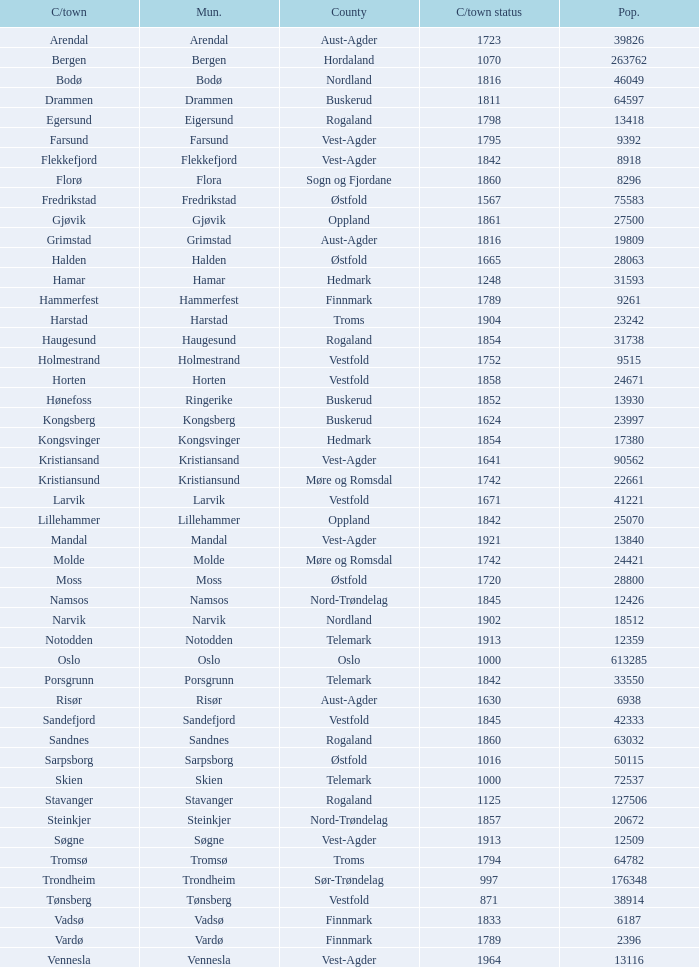Which municipality has a population of 24421? Molde. 